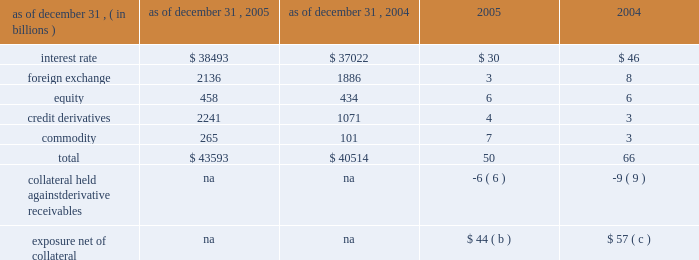Notional amounts and derivative receivables marked to market ( 201cmtm 201d ) notional amounts ( a ) derivative receivables mtm as of december 31 .
( a ) the notional amounts represent the gross sum of long and short third-party notional derivative contracts , excluding written options and foreign exchange spot contracts , which significantly exceed the possible credit losses that could arise from such transactions .
For most derivative transactions , the notional principal amount does not change hands ; it is used simply as a reference to calculate payments .
( b ) the firm held $ 33 billion of collateral against derivative receivables as of december 31 , 2005 , consisting of $ 27 billion in net cash received under credit support annexes to legally enforceable master netting agreements , and $ 6 billion of other liquid securities collateral .
The benefit of the $ 27 billion is reflected within the $ 50 billion of derivative receivables mtm .
Excluded from the $ 33 billion of collateral is $ 10 billion of collateral delivered by clients at the initiation of transactions ; this collateral secures exposure that could arise in the derivatives portfolio should the mtm of the client 2019s transactions move in the firm 2019s favor .
Also excluded are credit enhancements in the form of letters of credit and surety receivables .
( c ) the firm held $ 41 billion of collateral against derivative receivables as of december 31 , 2004 , consisting of $ 32 billion in net cash received under credit support annexes to legally enforceable master netting agreements , and $ 9 billion of other liquid securities collateral .
The benefit of the $ 32 billion is reflected within the $ 66 billion of derivative receivables mtm .
Excluded from the $ 41 billion of collateral is $ 10 billion of collateral delivered by clients at the initiation of transactions ; this collateral secures exposure that could arise in the derivatives portfolio should the mtm of the client 2019s transactions move in the firm 2019s favor .
Also excluded are credit enhancements in the form of letters of credit and surety receivables .
Management 2019s discussion and analysis jpmorgan chase & co .
68 jpmorgan chase & co .
/ 2005 annual report 1 year 2 years 5 years 10 years mdp avgavgdredre exposure profile of derivatives measures december 31 , 2005 ( in billions ) the following table summarizes the aggregate notional amounts and the reported derivative receivables ( i.e. , the mtm or fair value of the derivative contracts after taking into account the effects of legally enforceable master netting agreements ) at each of the dates indicated : the mtm of derivative receivables contracts represents the cost to replace the contracts at current market rates should the counterparty default .
When jpmorgan chase has more than one transaction outstanding with a counter- party , and a legally enforceable master netting agreement exists with that counterparty , the netted mtm exposure , less collateral held , represents , in the firm 2019s view , the appropriate measure of current credit risk .
While useful as a current view of credit exposure , the net mtm value of the derivative receivables does not capture the potential future variability of that credit exposure .
To capture the potential future variability of credit exposure , the firm calculates , on a client-by-client basis , three measures of potential derivatives-related credit loss : peak , derivative risk equivalent ( 201cdre 201d ) and average exposure ( 201cavg 201d ) .
These measures all incorporate netting and collateral benefits , where applicable .
Peak exposure to a counterparty is an extreme measure of exposure calculated at a 97.5% ( 97.5 % ) confidence level .
However , the total potential future credit risk embedded in the firm 2019s derivatives portfolio is not the simple sum of all peak client credit risks .
This is because , at the portfolio level , credit risk is reduced by the fact that when offsetting transactions are done with separate counter- parties , only one of the two trades can generate a credit loss , even if both counterparties were to default simultaneously .
The firm refers to this effect as market diversification , and the market-diversified peak ( 201cmdp 201d ) measure is a portfolio aggregation of counterparty peak measures , representing the maximum losses at the 97.5% ( 97.5 % ) confidence level that would occur if all coun- terparties defaulted under any one given market scenario and time frame .
Derivative risk equivalent ( 201cdre 201d ) exposure is a measure that expresses the riskiness of derivative exposure on a basis intended to be equivalent to the riskiness of loan exposures .
The measurement is done by equating the unexpected loss in a derivative counterparty exposure ( which takes into consideration both the loss volatility and the credit rating of the counterparty ) with the unexpected loss in a loan exposure ( which takes into consideration only the credit rating of the counterparty ) .
Dre is a less extreme measure of potential credit loss than peak and is the primary measure used by the firm for credit approval of derivative transactions .
Finally , average exposure ( 201cavg 201d ) is a measure of the expected mtm value of the firm 2019s derivative receivables at future time periods , including the benefit of collateral .
Avg exposure over the total life of the derivative contract is used as the primary metric for pricing purposes and is used to calculate credit capital and the credit valuation adjustment ( 201ccva 201d ) , as further described below .
Average exposure was $ 36 billion and $ 38 billion at december 31 , 2005 and 2004 , respectively , compared with derivative receivables mtm net of other highly liquid collateral of $ 44 billion and $ 57 billion at december 31 , 2005 and 2004 , respectively .
The graph below shows exposure profiles to derivatives over the next 10 years as calculated by the mdp , dre and avg metrics .
All three measures generally show declining exposure after the first year , if no new trades were added to the portfolio. .
Based on the notional amounts and derivative receivables marked to market what was percentage change in interest rate? 
Computations: ((38493 - 37022) / 37022)
Answer: 0.03973. 